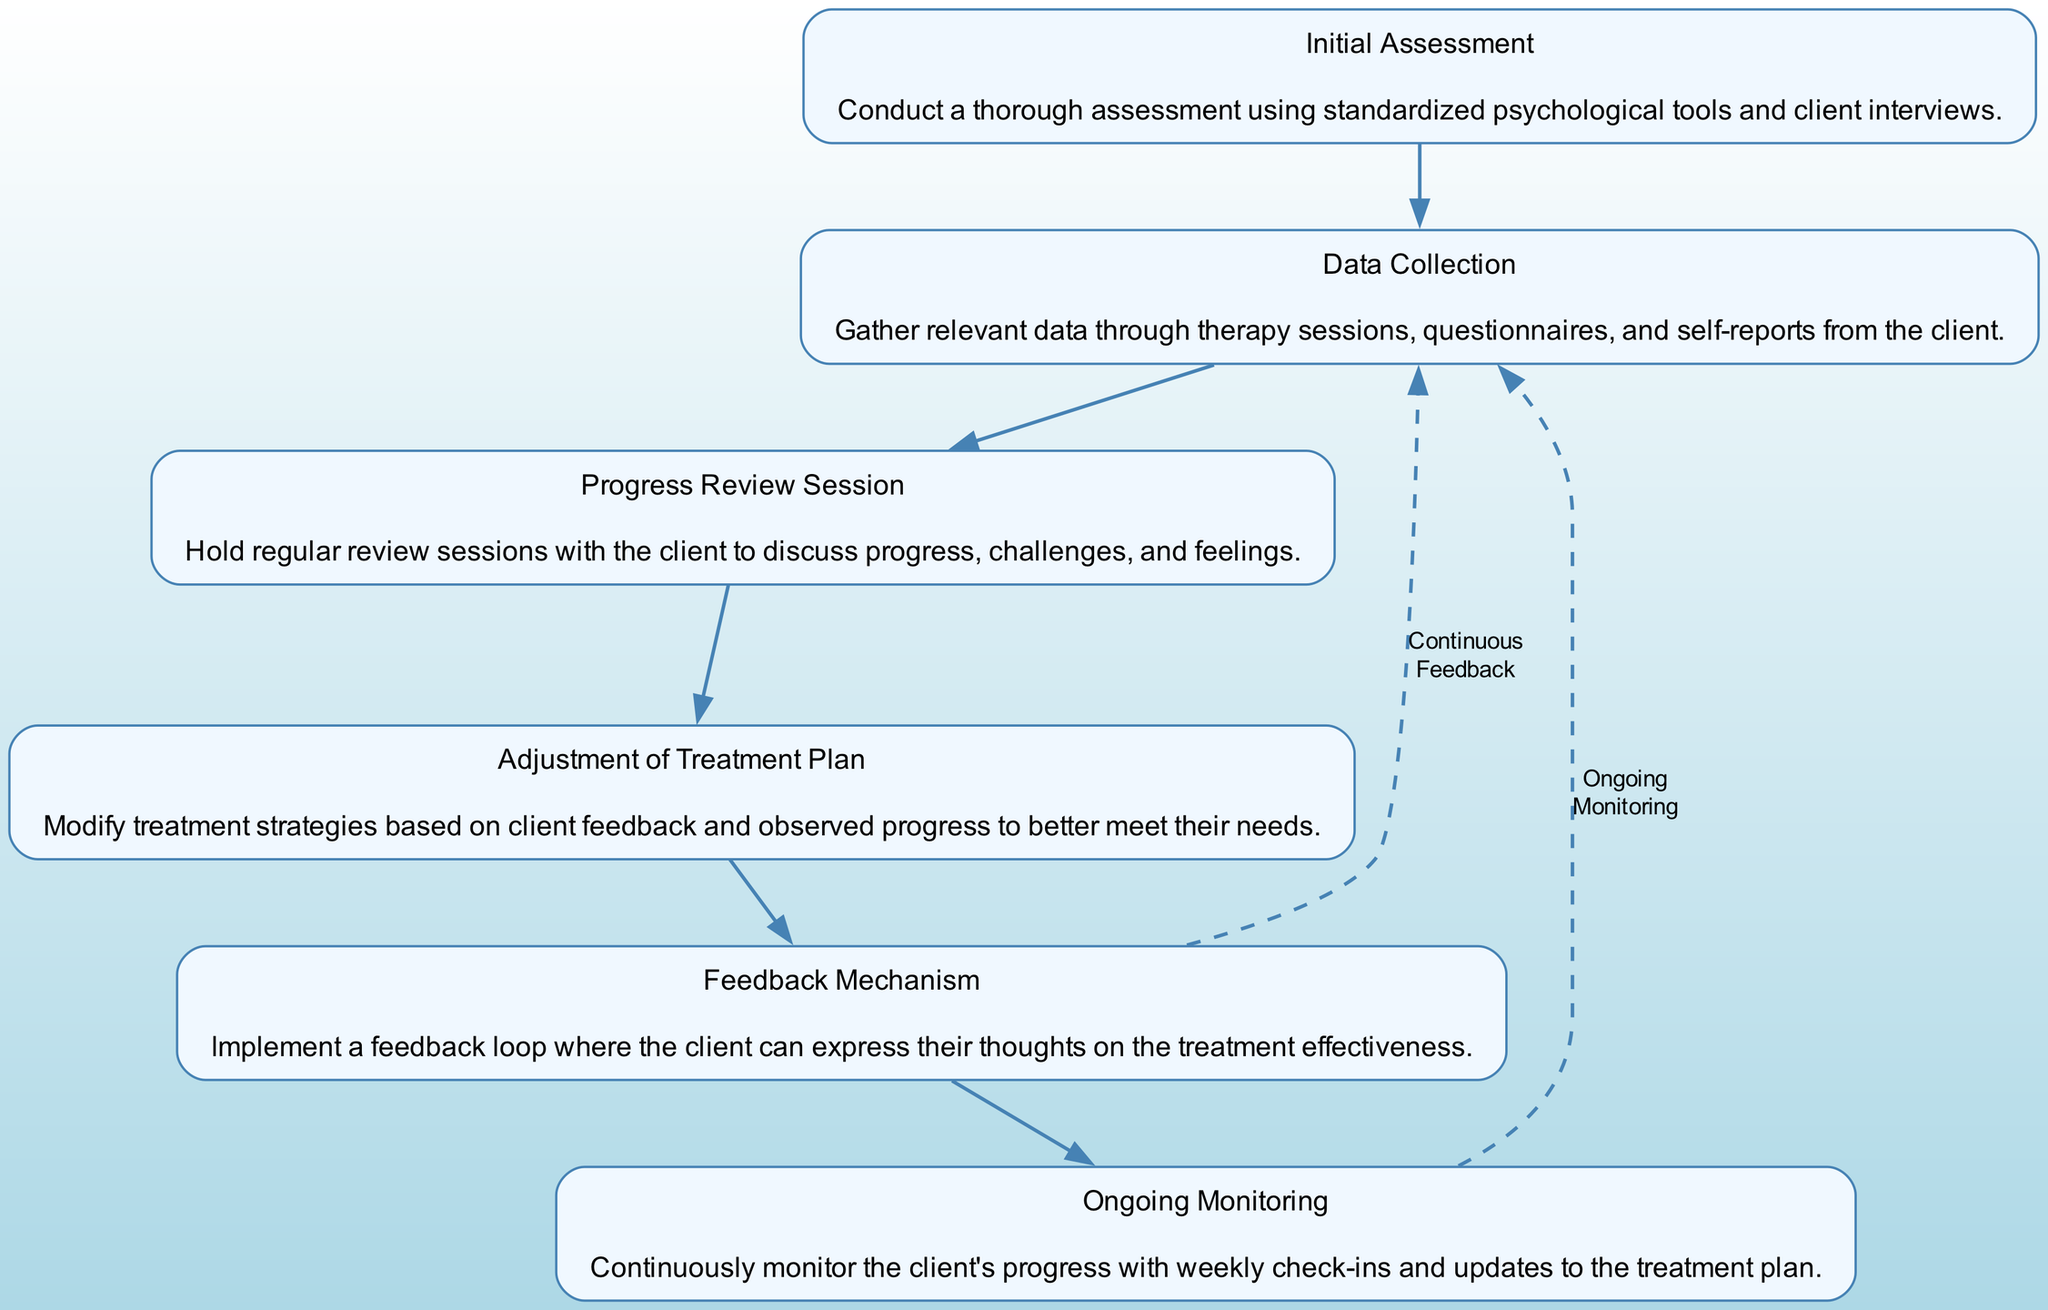What is the first step in the evaluation process? The first node in the flow chart is labeled "Initial Assessment," which indicates that this is the starting point for evaluating a client's progress through thorough assessment techniques.
Answer: Initial Assessment How many total steps are in the flow chart? By counting the nodes present in the flow chart, we identify six distinct steps. Each step includes a unique aspect of the evaluation process.
Answer: 6 Which step follows the "Data Collection"? In the flow chart, the step that directly follows "Data Collection" is "Progress Review Session." This can be deduced from the sequential arrangement of the nodes.
Answer: Progress Review Session What action is indicated by the feedback mechanism? The feedback mechanism in the flow chart allows for the client to express their thoughts on the treatment effectiveness, which connects to the improvement of future sessions and strategies.
Answer: Client feedback Which two steps are connected by a dashed edge in the diagram? The dashed edge connects "Feedback Mechanism" and "Data Collection." This indicates a continuous feedback loop in the evaluation process that encourages revisiting data collection based on client input.
Answer: Feedback Mechanism and Data Collection What is the outcome of the "Ongoing Monitoring"? The "Ongoing Monitoring" step leads back to "Data Collection," indicating that monitoring ensures an updated and responsive approach to treatment based on continual progress checks.
Answer: Data Collection 